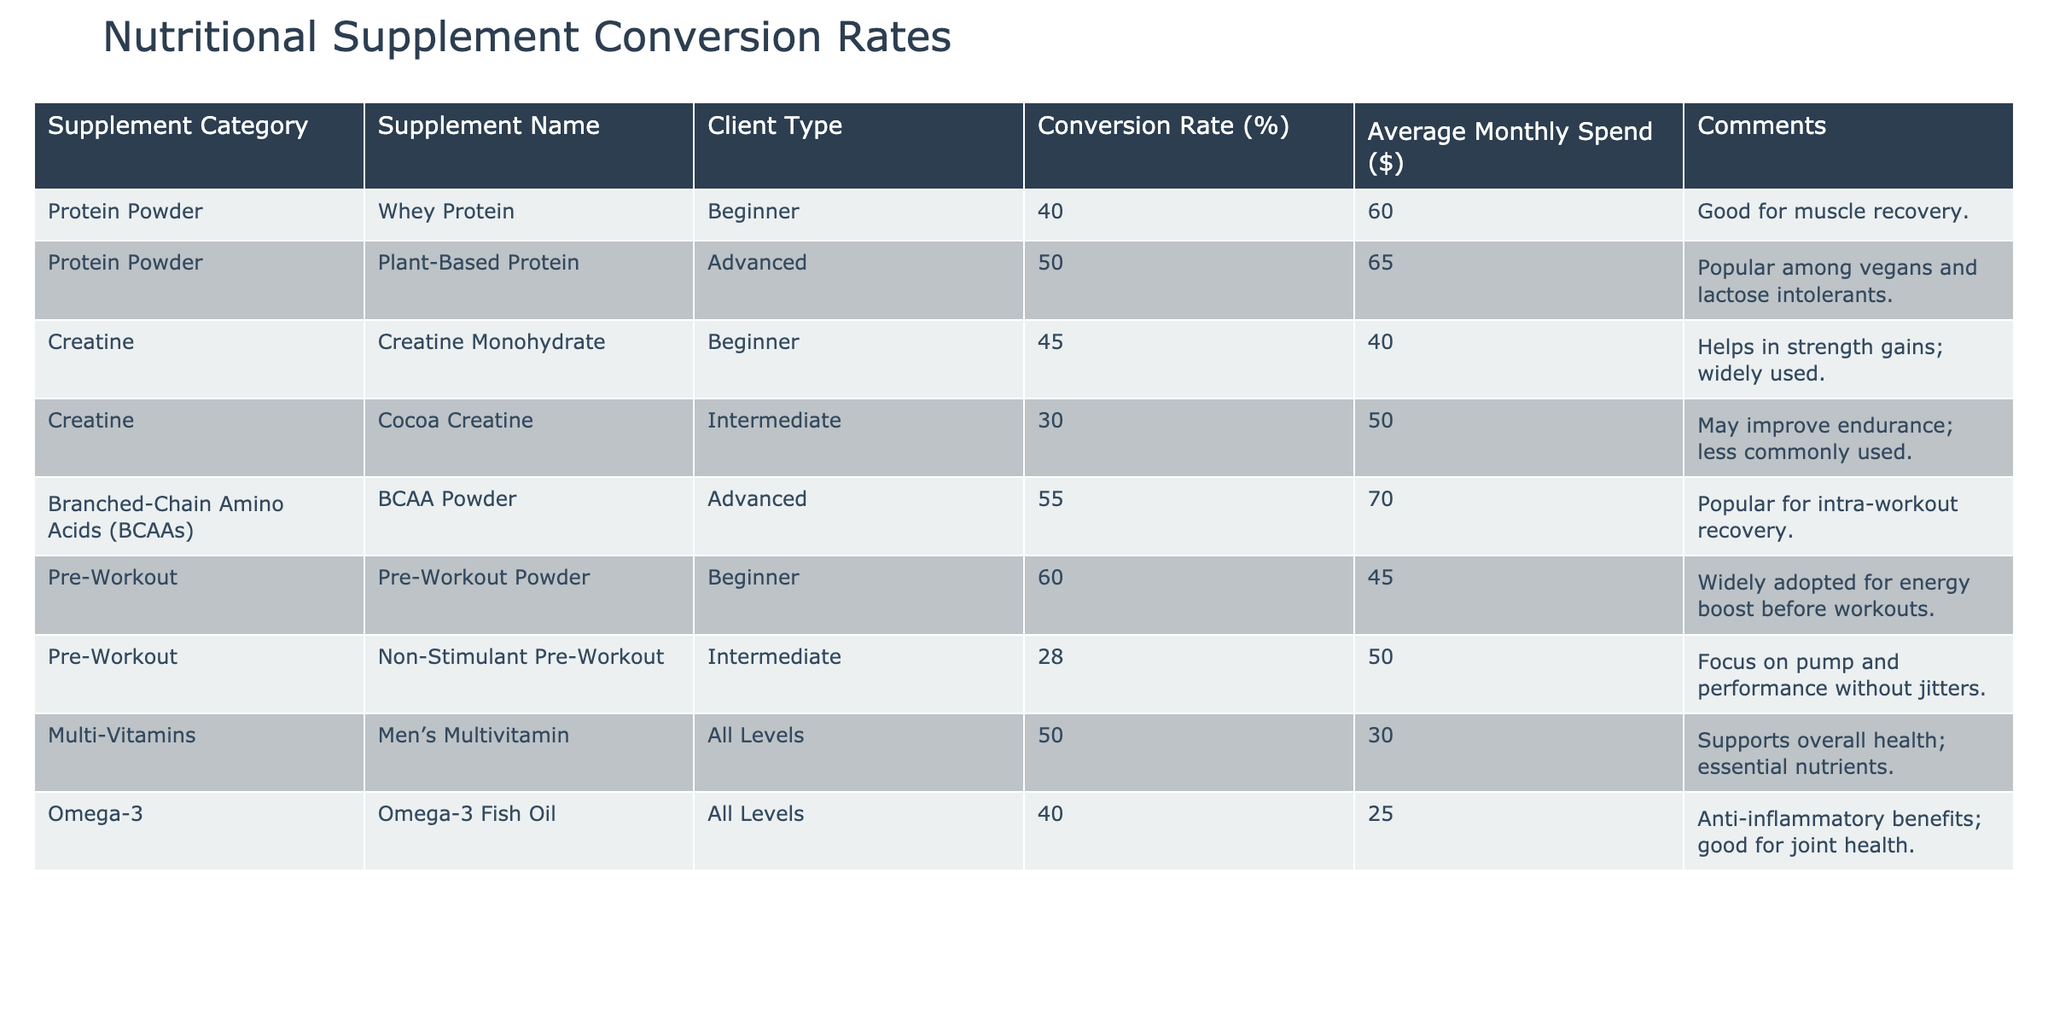What is the conversion rate for Whey Protein among Beginners? The table shows the entry for Whey Protein under the Beginner client type with a conversion rate of 40%. Thus, I can retrieve this specific value directly from the table.
Answer: 40% Which supplement has the highest average monthly spend? To find the supplement with the highest average monthly spend, I compare the Average Monthly Spend column: Whey Protein ($60), Plant-Based Protein ($65), BCAA Powder ($70), Pre-Workout Powder ($45), Non-Stimulant Pre-Workout ($50), Men’s Multivitamin ($30), Omega-3 Fish Oil ($25), and Creatine Monohydrate ($40). The highest value is BCAA Powder at $70.
Answer: BCAA Powder Is it true that Omega-3 Fish Oil has a higher conversion rate than Cocoa Creatine? Comparing the conversion rates, Omega-3 Fish Oil has a conversion rate of 40% while Cocoa Creatine has a conversion rate of 30%. Since 40% is greater than 30%, the statement is true.
Answer: Yes What is the average conversion rate for all supplements in the table? To calculate the average conversion rate, I need to sum the conversion rates for all supplements: 40 + 50 + 45 + 30 + 55 + 60 + 50 + 40 = 370. There are 8 supplements, so the average conversion rate is 370 / 8 = 46.25.
Answer: 46.25% Which Client Type has the highest conversion rate and what is it? Looking at the conversion rates for the client types: Beginner (at 40% and 60%), Intermediate (at 30% and 28%), Advanced (at 50% and 55%), and All Levels (at 50% and 40%), the maximum conversion rate among these is for Advanced clients at 55%.
Answer: Advanced, 55% How does the average monthly spend for Advanced clients compare to that of Beginners? The average monthly spend for Advanced clients can be calculated by averaging the values for Plant-Based Protein ($65) and BCAA Powder ($70), which totals $135. Dividing this by 2 gives $67.5. The average monthly spend for Beginners is $60. Thus, $67.5 (Advanced) is greater than $60 (Beginners).
Answer: Advanced Clients spend more, $67.5 vs. $60 What is the conversion rate for Non-Stimulant Pre-Workout? The table indicates that the conversion rate for Non-Stimulant Pre-Workout is 28%, as shown directly in the row corresponding to that specific supplement.
Answer: 28% Which supplement would be most effective for an Advanced client aimed at muscle recovery? In the table, for Advanced clients focusing on muscle recovery, BCAA Powder shows the highest conversion rate of 55%, which indicates a strong preference for this supplement among that client type.
Answer: BCAA Powder Is Creatine Monohydrate cheaper than Whey Protein? The average monthly spend for Creatine Monohydrate is $40 and for Whey Protein, it is $60. Since $40 is less than $60, Creatine Monohydrate is cheaper than Whey Protein.
Answer: Yes 